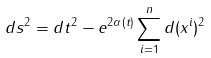Convert formula to latex. <formula><loc_0><loc_0><loc_500><loc_500>d s ^ { 2 } = d t ^ { 2 } - e ^ { 2 \alpha ( t ) } \sum _ { i = 1 } ^ { n } d ( x ^ { i } ) ^ { 2 }</formula> 